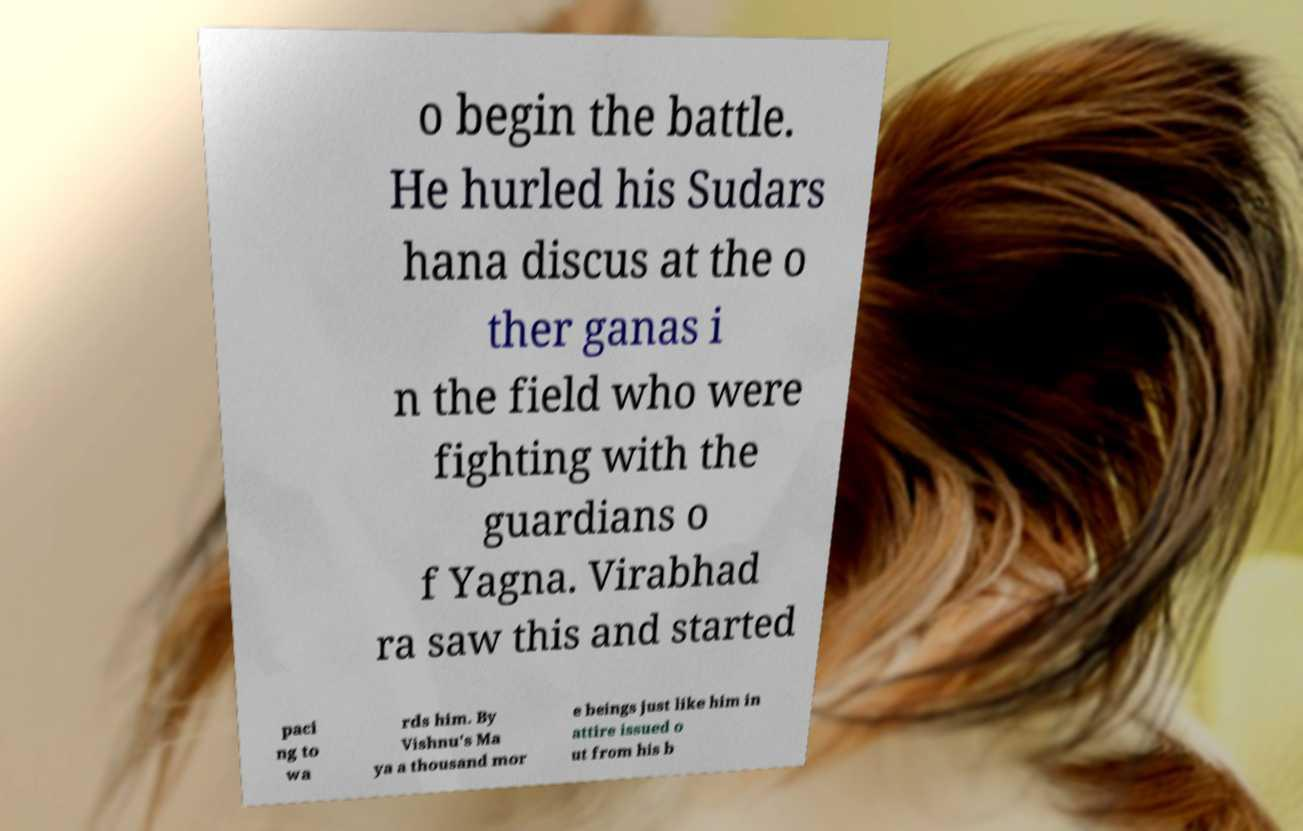There's text embedded in this image that I need extracted. Can you transcribe it verbatim? o begin the battle. He hurled his Sudars hana discus at the o ther ganas i n the field who were fighting with the guardians o f Yagna. Virabhad ra saw this and started paci ng to wa rds him. By Vishnu's Ma ya a thousand mor e beings just like him in attire issued o ut from his b 